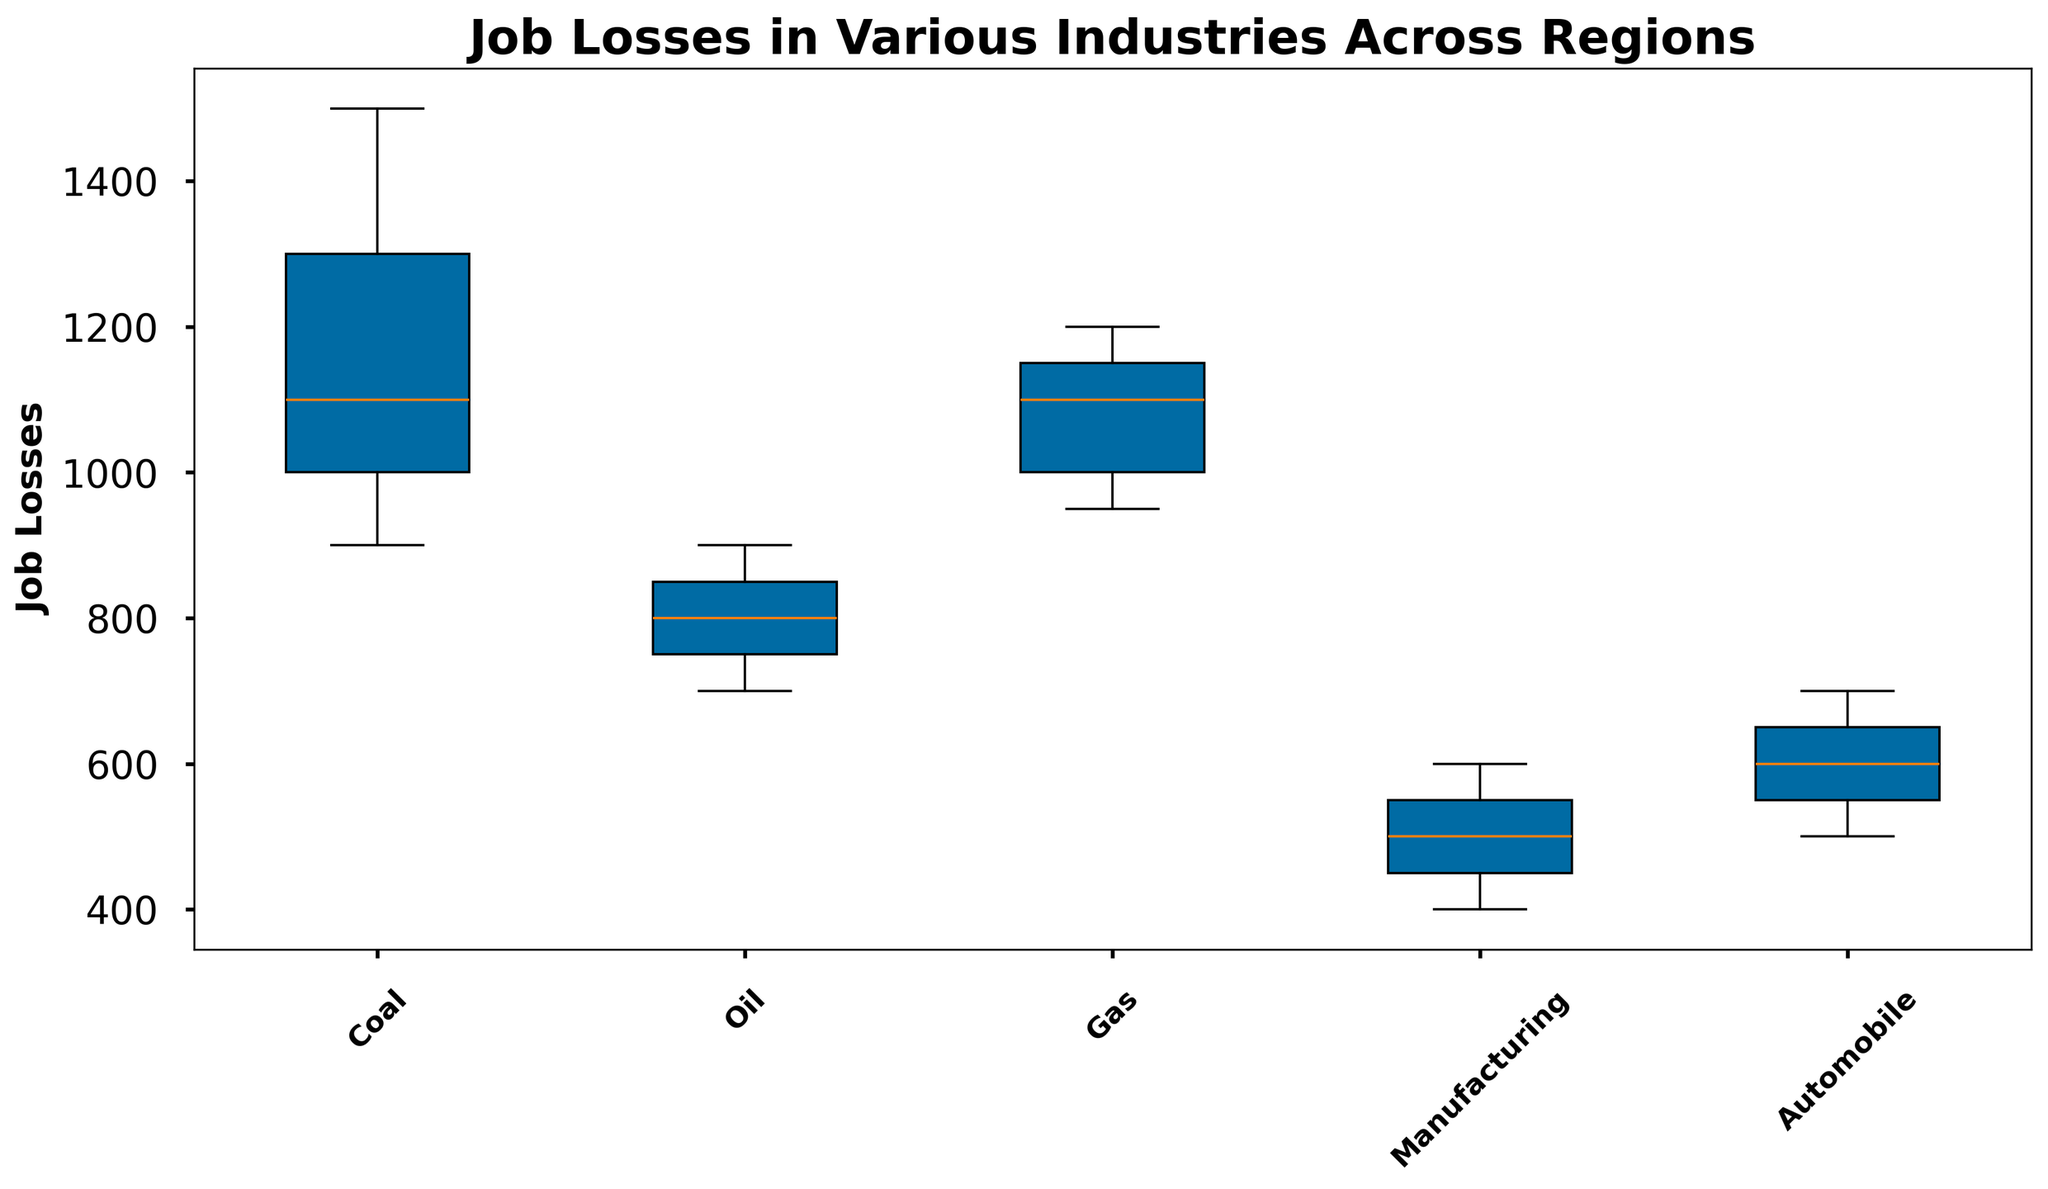What's the median job loss in the automobile industry across all regions? Identify the box plot corresponding to the automobile industry. The median is indicated by the line within the box.
Answer: 600 Which industry shows the highest variance in job losses across regions? Observe the width of the boxes and the lengths of the whiskers. The coal industry shows the highest variance.
Answer: Coal Which region faces the least job losses in the gas industry? Compare the ends of the whiskers for each region in the gas industry box plot. The South-West region shows the least job losses.
Answer: South-West Compare the median job losses between the coal and manufacturing industries. Which one is higher, and by how much? Find the medians marked in the boxes of the coal and manufacturing industries. The median of the coal industry is 1100, and for manufacturing, it is 500. The difference is 1100 - 500.
Answer: The coal industry is higher by 600 If you sum the median job losses of the oil and gas industries, what would the total be? Determine the medians for both the oil and gas industries and then sum them up. The medians are 800 and 1100 respectively. 800 + 1100 = 1900.
Answer: 1900 Which industry has the lowest minimum job losses across regions? Look for the lowest whisker tip across all the industries. Manufacturing has the lowest minimum job losses.
Answer: Manufacturing Compare the interquartile range (IQR) of job losses between the oil and the automobile industries. Which has a smaller IQR? The IQR is the range between the lower quartile and the upper quartile (the box height). The automobile industry has a smaller box compared to the oil industry.
Answer: Automobile In which industry is the job losses range between the first quartile (Q1) and the third quartile (Q3) smallest? Identify the boxes of each industry and compare their heights. The manufacturing industry has the smallest range.
Answer: Manufacturing Which region has the highest upper whisker for the coal industry, and what is the job loss value? Look at the upper whiskers for each region in the coal industry box plot. The North-East region has the highest whisker.
Answer: 1500 